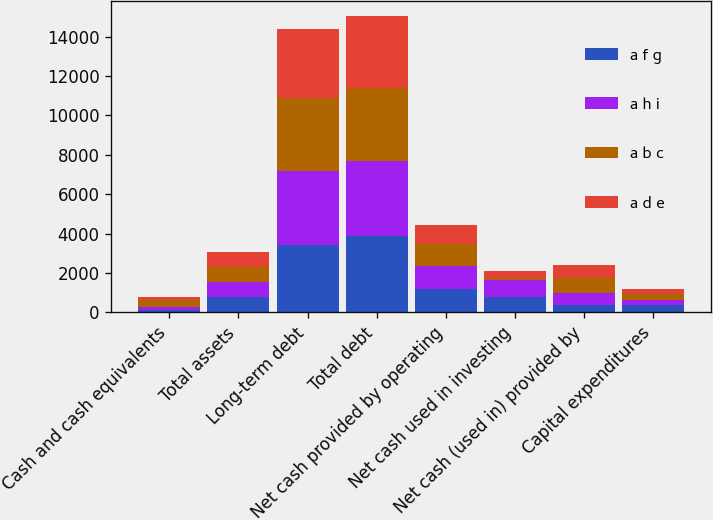Convert chart to OTSL. <chart><loc_0><loc_0><loc_500><loc_500><stacked_bar_chart><ecel><fcel>Cash and cash equivalents<fcel>Total assets<fcel>Long-term debt<fcel>Total debt<fcel>Net cash provided by operating<fcel>Net cash used in investing<fcel>Net cash (used in) provided by<fcel>Capital expenditures<nl><fcel>a f g<fcel>135<fcel>769.5<fcel>3429<fcel>3893<fcel>1200<fcel>801<fcel>401<fcel>383<nl><fcel>a h i<fcel>137<fcel>769.5<fcel>3748<fcel>3784<fcel>1175<fcel>830<fcel>592<fcel>252<nl><fcel>a b c<fcel>359<fcel>769.5<fcel>3728<fcel>3734<fcel>1116<fcel>127<fcel>738<fcel>293<nl><fcel>a d e<fcel>133<fcel>769.5<fcel>3492<fcel>3651<fcel>967<fcel>362<fcel>664<fcel>263<nl></chart> 